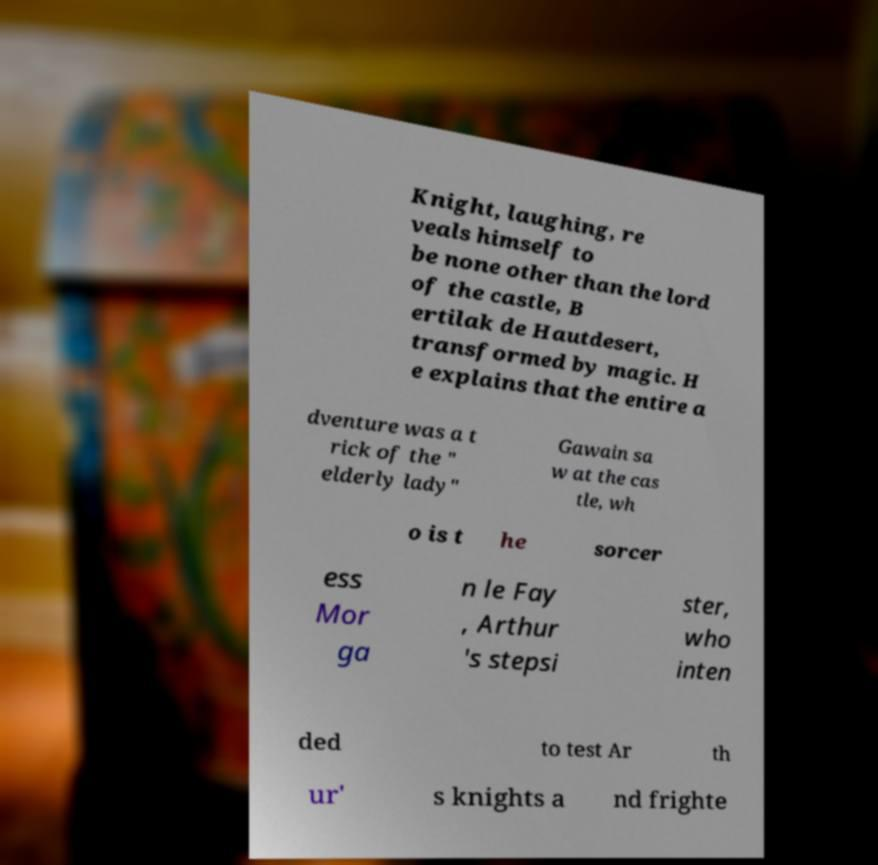For documentation purposes, I need the text within this image transcribed. Could you provide that? Knight, laughing, re veals himself to be none other than the lord of the castle, B ertilak de Hautdesert, transformed by magic. H e explains that the entire a dventure was a t rick of the " elderly lady" Gawain sa w at the cas tle, wh o is t he sorcer ess Mor ga n le Fay , Arthur 's stepsi ster, who inten ded to test Ar th ur' s knights a nd frighte 